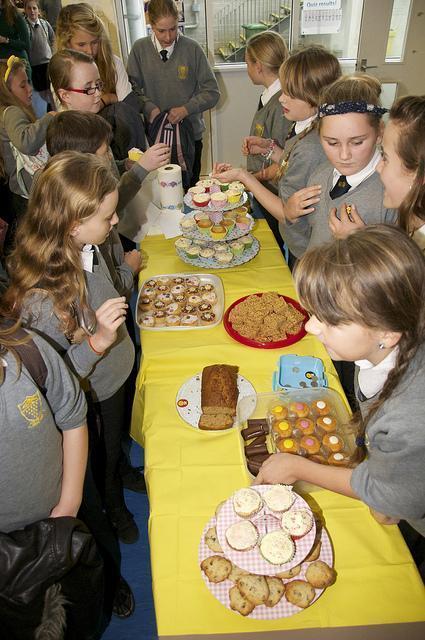How many cakes are there?
Give a very brief answer. 2. How many people are in the picture?
Give a very brief answer. 13. 